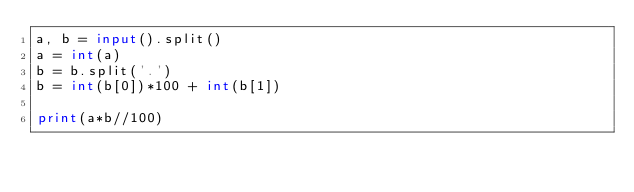Convert code to text. <code><loc_0><loc_0><loc_500><loc_500><_Python_>a, b = input().split()
a = int(a)
b = b.split('.')
b = int(b[0])*100 + int(b[1])

print(a*b//100)
</code> 